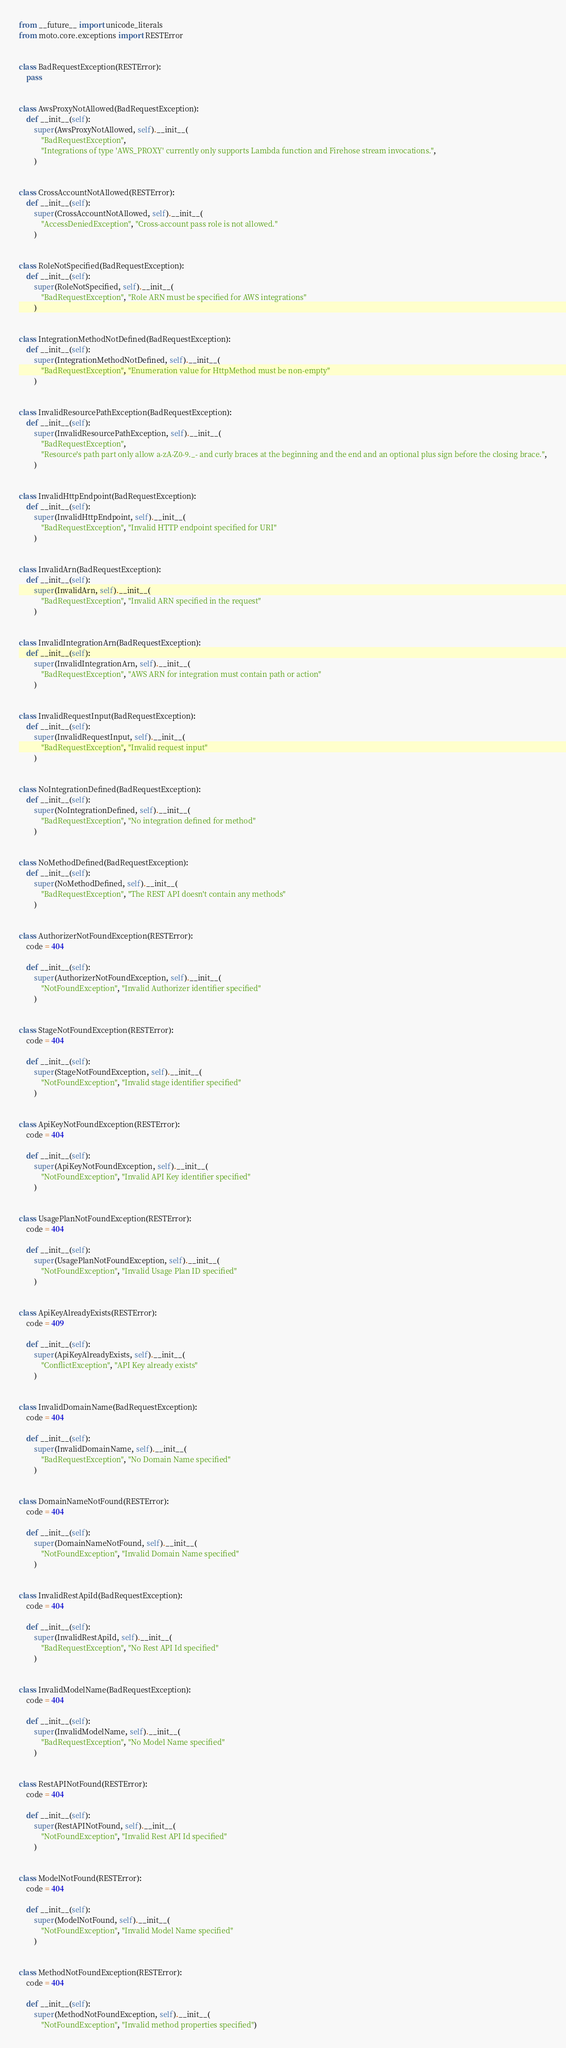<code> <loc_0><loc_0><loc_500><loc_500><_Python_>from __future__ import unicode_literals
from moto.core.exceptions import RESTError


class BadRequestException(RESTError):
    pass


class AwsProxyNotAllowed(BadRequestException):
    def __init__(self):
        super(AwsProxyNotAllowed, self).__init__(
            "BadRequestException",
            "Integrations of type 'AWS_PROXY' currently only supports Lambda function and Firehose stream invocations.",
        )


class CrossAccountNotAllowed(RESTError):
    def __init__(self):
        super(CrossAccountNotAllowed, self).__init__(
            "AccessDeniedException", "Cross-account pass role is not allowed."
        )


class RoleNotSpecified(BadRequestException):
    def __init__(self):
        super(RoleNotSpecified, self).__init__(
            "BadRequestException", "Role ARN must be specified for AWS integrations"
        )


class IntegrationMethodNotDefined(BadRequestException):
    def __init__(self):
        super(IntegrationMethodNotDefined, self).__init__(
            "BadRequestException", "Enumeration value for HttpMethod must be non-empty"
        )


class InvalidResourcePathException(BadRequestException):
    def __init__(self):
        super(InvalidResourcePathException, self).__init__(
            "BadRequestException",
            "Resource's path part only allow a-zA-Z0-9._- and curly braces at the beginning and the end and an optional plus sign before the closing brace.",
        )


class InvalidHttpEndpoint(BadRequestException):
    def __init__(self):
        super(InvalidHttpEndpoint, self).__init__(
            "BadRequestException", "Invalid HTTP endpoint specified for URI"
        )


class InvalidArn(BadRequestException):
    def __init__(self):
        super(InvalidArn, self).__init__(
            "BadRequestException", "Invalid ARN specified in the request"
        )


class InvalidIntegrationArn(BadRequestException):
    def __init__(self):
        super(InvalidIntegrationArn, self).__init__(
            "BadRequestException", "AWS ARN for integration must contain path or action"
        )


class InvalidRequestInput(BadRequestException):
    def __init__(self):
        super(InvalidRequestInput, self).__init__(
            "BadRequestException", "Invalid request input"
        )


class NoIntegrationDefined(BadRequestException):
    def __init__(self):
        super(NoIntegrationDefined, self).__init__(
            "BadRequestException", "No integration defined for method"
        )


class NoMethodDefined(BadRequestException):
    def __init__(self):
        super(NoMethodDefined, self).__init__(
            "BadRequestException", "The REST API doesn't contain any methods"
        )


class AuthorizerNotFoundException(RESTError):
    code = 404

    def __init__(self):
        super(AuthorizerNotFoundException, self).__init__(
            "NotFoundException", "Invalid Authorizer identifier specified"
        )


class StageNotFoundException(RESTError):
    code = 404

    def __init__(self):
        super(StageNotFoundException, self).__init__(
            "NotFoundException", "Invalid stage identifier specified"
        )


class ApiKeyNotFoundException(RESTError):
    code = 404

    def __init__(self):
        super(ApiKeyNotFoundException, self).__init__(
            "NotFoundException", "Invalid API Key identifier specified"
        )


class UsagePlanNotFoundException(RESTError):
    code = 404

    def __init__(self):
        super(UsagePlanNotFoundException, self).__init__(
            "NotFoundException", "Invalid Usage Plan ID specified"
        )


class ApiKeyAlreadyExists(RESTError):
    code = 409

    def __init__(self):
        super(ApiKeyAlreadyExists, self).__init__(
            "ConflictException", "API Key already exists"
        )


class InvalidDomainName(BadRequestException):
    code = 404

    def __init__(self):
        super(InvalidDomainName, self).__init__(
            "BadRequestException", "No Domain Name specified"
        )


class DomainNameNotFound(RESTError):
    code = 404

    def __init__(self):
        super(DomainNameNotFound, self).__init__(
            "NotFoundException", "Invalid Domain Name specified"
        )


class InvalidRestApiId(BadRequestException):
    code = 404

    def __init__(self):
        super(InvalidRestApiId, self).__init__(
            "BadRequestException", "No Rest API Id specified"
        )


class InvalidModelName(BadRequestException):
    code = 404

    def __init__(self):
        super(InvalidModelName, self).__init__(
            "BadRequestException", "No Model Name specified"
        )


class RestAPINotFound(RESTError):
    code = 404

    def __init__(self):
        super(RestAPINotFound, self).__init__(
            "NotFoundException", "Invalid Rest API Id specified"
        )


class ModelNotFound(RESTError):
    code = 404

    def __init__(self):
        super(ModelNotFound, self).__init__(
            "NotFoundException", "Invalid Model Name specified"
        )


class MethodNotFoundException(RESTError):
    code = 404

    def __init__(self):
        super(MethodNotFoundException, self).__init__(
            "NotFoundException", "Invalid method properties specified")
</code> 